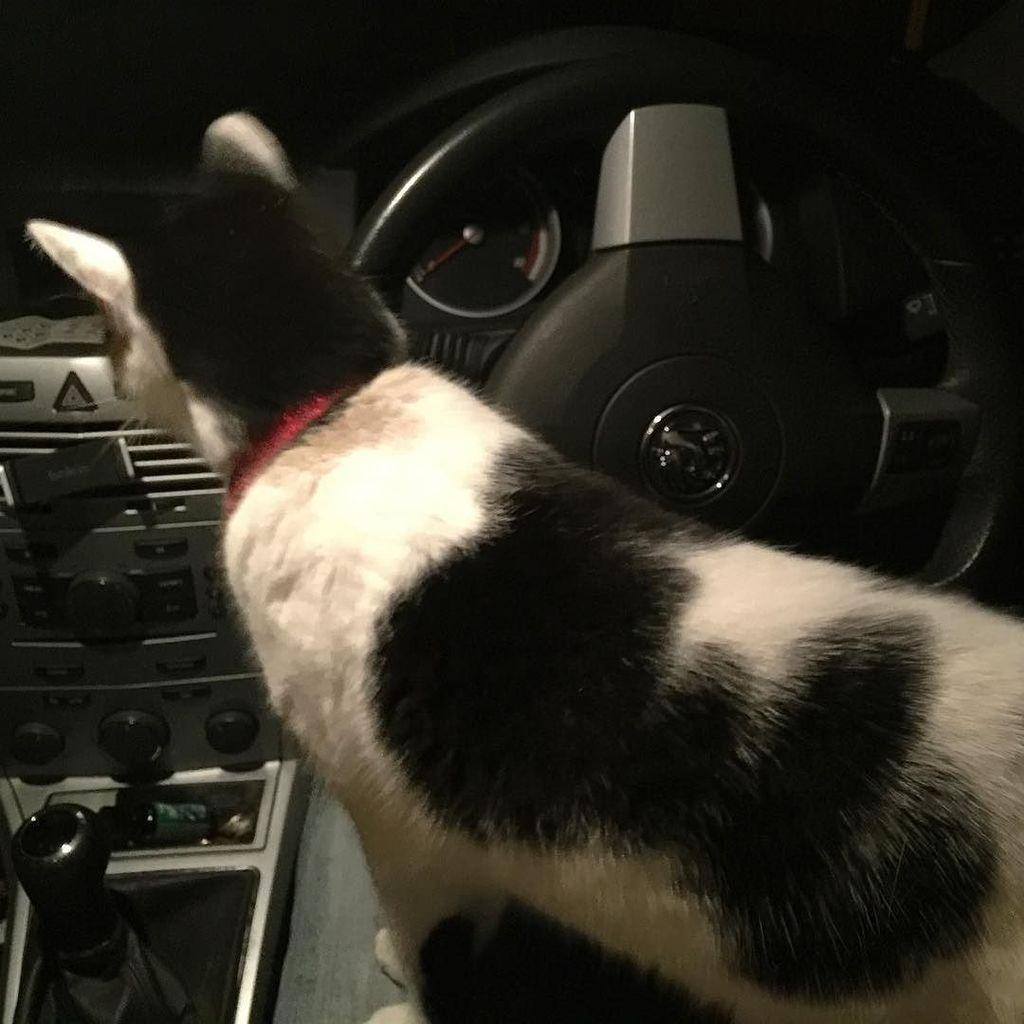What type of animal is present in the image? There is a cat in the image. Where is the cat located in the image? The cat is standing inside a vehicle. What type of war is being fought in the image? There is no war present in the image; it features a cat standing inside a vehicle. What channel is the cat watching in the image? There is no television or channel visible in the image; it only shows a cat inside a vehicle. 